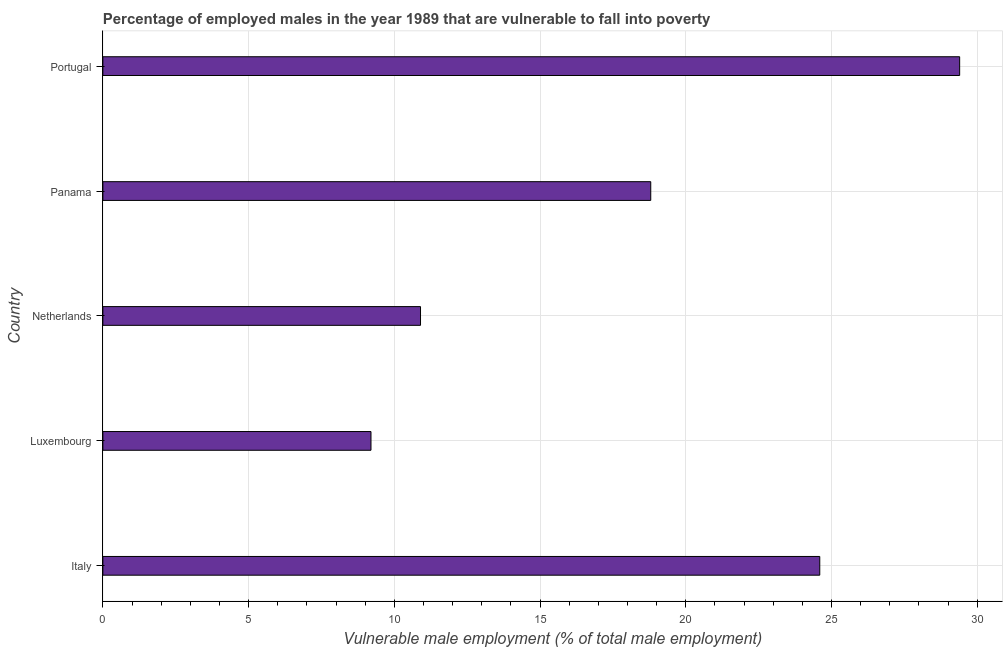Does the graph contain any zero values?
Offer a very short reply. No. Does the graph contain grids?
Your answer should be compact. Yes. What is the title of the graph?
Keep it short and to the point. Percentage of employed males in the year 1989 that are vulnerable to fall into poverty. What is the label or title of the X-axis?
Offer a terse response. Vulnerable male employment (% of total male employment). What is the label or title of the Y-axis?
Your answer should be compact. Country. What is the percentage of employed males who are vulnerable to fall into poverty in Italy?
Make the answer very short. 24.6. Across all countries, what is the maximum percentage of employed males who are vulnerable to fall into poverty?
Your answer should be compact. 29.4. Across all countries, what is the minimum percentage of employed males who are vulnerable to fall into poverty?
Your response must be concise. 9.2. In which country was the percentage of employed males who are vulnerable to fall into poverty maximum?
Your response must be concise. Portugal. In which country was the percentage of employed males who are vulnerable to fall into poverty minimum?
Your response must be concise. Luxembourg. What is the sum of the percentage of employed males who are vulnerable to fall into poverty?
Ensure brevity in your answer.  92.9. What is the average percentage of employed males who are vulnerable to fall into poverty per country?
Keep it short and to the point. 18.58. What is the median percentage of employed males who are vulnerable to fall into poverty?
Make the answer very short. 18.8. In how many countries, is the percentage of employed males who are vulnerable to fall into poverty greater than 24 %?
Provide a succinct answer. 2. What is the ratio of the percentage of employed males who are vulnerable to fall into poverty in Italy to that in Luxembourg?
Give a very brief answer. 2.67. Is the difference between the percentage of employed males who are vulnerable to fall into poverty in Italy and Portugal greater than the difference between any two countries?
Your answer should be compact. No. Is the sum of the percentage of employed males who are vulnerable to fall into poverty in Italy and Panama greater than the maximum percentage of employed males who are vulnerable to fall into poverty across all countries?
Keep it short and to the point. Yes. What is the difference between the highest and the lowest percentage of employed males who are vulnerable to fall into poverty?
Provide a succinct answer. 20.2. In how many countries, is the percentage of employed males who are vulnerable to fall into poverty greater than the average percentage of employed males who are vulnerable to fall into poverty taken over all countries?
Ensure brevity in your answer.  3. Are all the bars in the graph horizontal?
Your answer should be very brief. Yes. How many countries are there in the graph?
Ensure brevity in your answer.  5. What is the difference between two consecutive major ticks on the X-axis?
Your answer should be compact. 5. What is the Vulnerable male employment (% of total male employment) in Italy?
Offer a very short reply. 24.6. What is the Vulnerable male employment (% of total male employment) in Luxembourg?
Keep it short and to the point. 9.2. What is the Vulnerable male employment (% of total male employment) in Netherlands?
Provide a succinct answer. 10.9. What is the Vulnerable male employment (% of total male employment) of Panama?
Offer a terse response. 18.8. What is the Vulnerable male employment (% of total male employment) of Portugal?
Your answer should be very brief. 29.4. What is the difference between the Vulnerable male employment (% of total male employment) in Italy and Panama?
Your answer should be very brief. 5.8. What is the difference between the Vulnerable male employment (% of total male employment) in Luxembourg and Panama?
Your response must be concise. -9.6. What is the difference between the Vulnerable male employment (% of total male employment) in Luxembourg and Portugal?
Offer a very short reply. -20.2. What is the difference between the Vulnerable male employment (% of total male employment) in Netherlands and Portugal?
Keep it short and to the point. -18.5. What is the ratio of the Vulnerable male employment (% of total male employment) in Italy to that in Luxembourg?
Your answer should be very brief. 2.67. What is the ratio of the Vulnerable male employment (% of total male employment) in Italy to that in Netherlands?
Ensure brevity in your answer.  2.26. What is the ratio of the Vulnerable male employment (% of total male employment) in Italy to that in Panama?
Offer a very short reply. 1.31. What is the ratio of the Vulnerable male employment (% of total male employment) in Italy to that in Portugal?
Your answer should be compact. 0.84. What is the ratio of the Vulnerable male employment (% of total male employment) in Luxembourg to that in Netherlands?
Offer a very short reply. 0.84. What is the ratio of the Vulnerable male employment (% of total male employment) in Luxembourg to that in Panama?
Provide a short and direct response. 0.49. What is the ratio of the Vulnerable male employment (% of total male employment) in Luxembourg to that in Portugal?
Your answer should be very brief. 0.31. What is the ratio of the Vulnerable male employment (% of total male employment) in Netherlands to that in Panama?
Offer a terse response. 0.58. What is the ratio of the Vulnerable male employment (% of total male employment) in Netherlands to that in Portugal?
Provide a short and direct response. 0.37. What is the ratio of the Vulnerable male employment (% of total male employment) in Panama to that in Portugal?
Keep it short and to the point. 0.64. 